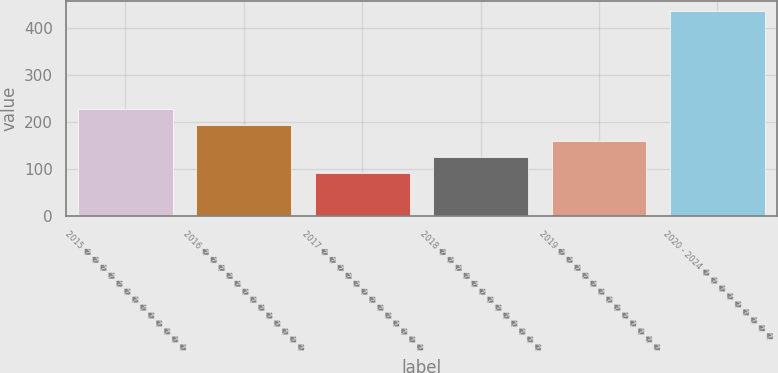Convert chart to OTSL. <chart><loc_0><loc_0><loc_500><loc_500><bar_chart><fcel>2015 � � � � � � � � � � � � �<fcel>2016 � � � � � � � � � � � � �<fcel>2017 � � � � � � � � � � � � �<fcel>2018 � � � � � � � � � � � � �<fcel>2019 � � � � � � � � � � � � �<fcel>2020 - 2024 � � � � � � � � �<nl><fcel>228.6<fcel>194.2<fcel>91<fcel>125.4<fcel>159.8<fcel>435<nl></chart> 